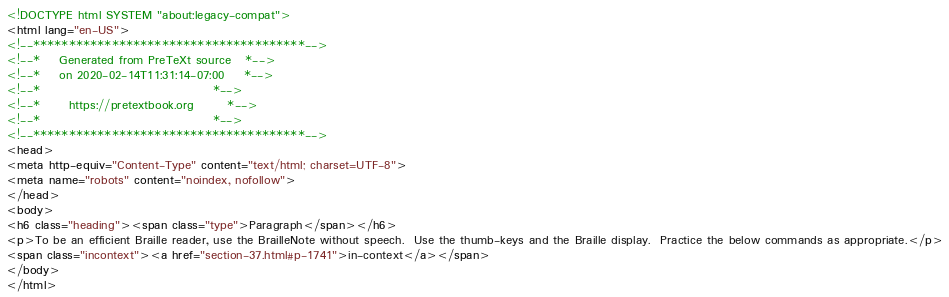Convert code to text. <code><loc_0><loc_0><loc_500><loc_500><_HTML_><!DOCTYPE html SYSTEM "about:legacy-compat">
<html lang="en-US">
<!--**************************************-->
<!--*    Generated from PreTeXt source   *-->
<!--*    on 2020-02-14T11:31:14-07:00    *-->
<!--*                                    *-->
<!--*      https://pretextbook.org       *-->
<!--*                                    *-->
<!--**************************************-->
<head>
<meta http-equiv="Content-Type" content="text/html; charset=UTF-8">
<meta name="robots" content="noindex, nofollow">
</head>
<body>
<h6 class="heading"><span class="type">Paragraph</span></h6>
<p>To be an efficient Braille reader, use the BrailleNote without speech.  Use the thumb-keys and the Braille display.  Practice the below commands as appropriate.</p>
<span class="incontext"><a href="section-37.html#p-1741">in-context</a></span>
</body>
</html>
</code> 